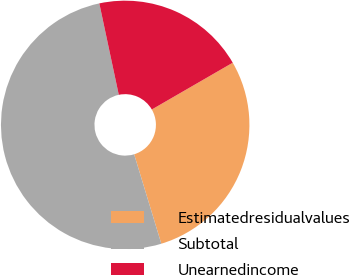Convert chart. <chart><loc_0><loc_0><loc_500><loc_500><pie_chart><fcel>Estimatedresidualvalues<fcel>Subtotal<fcel>Unearnedincome<nl><fcel>28.65%<fcel>51.36%<fcel>20.0%<nl></chart> 